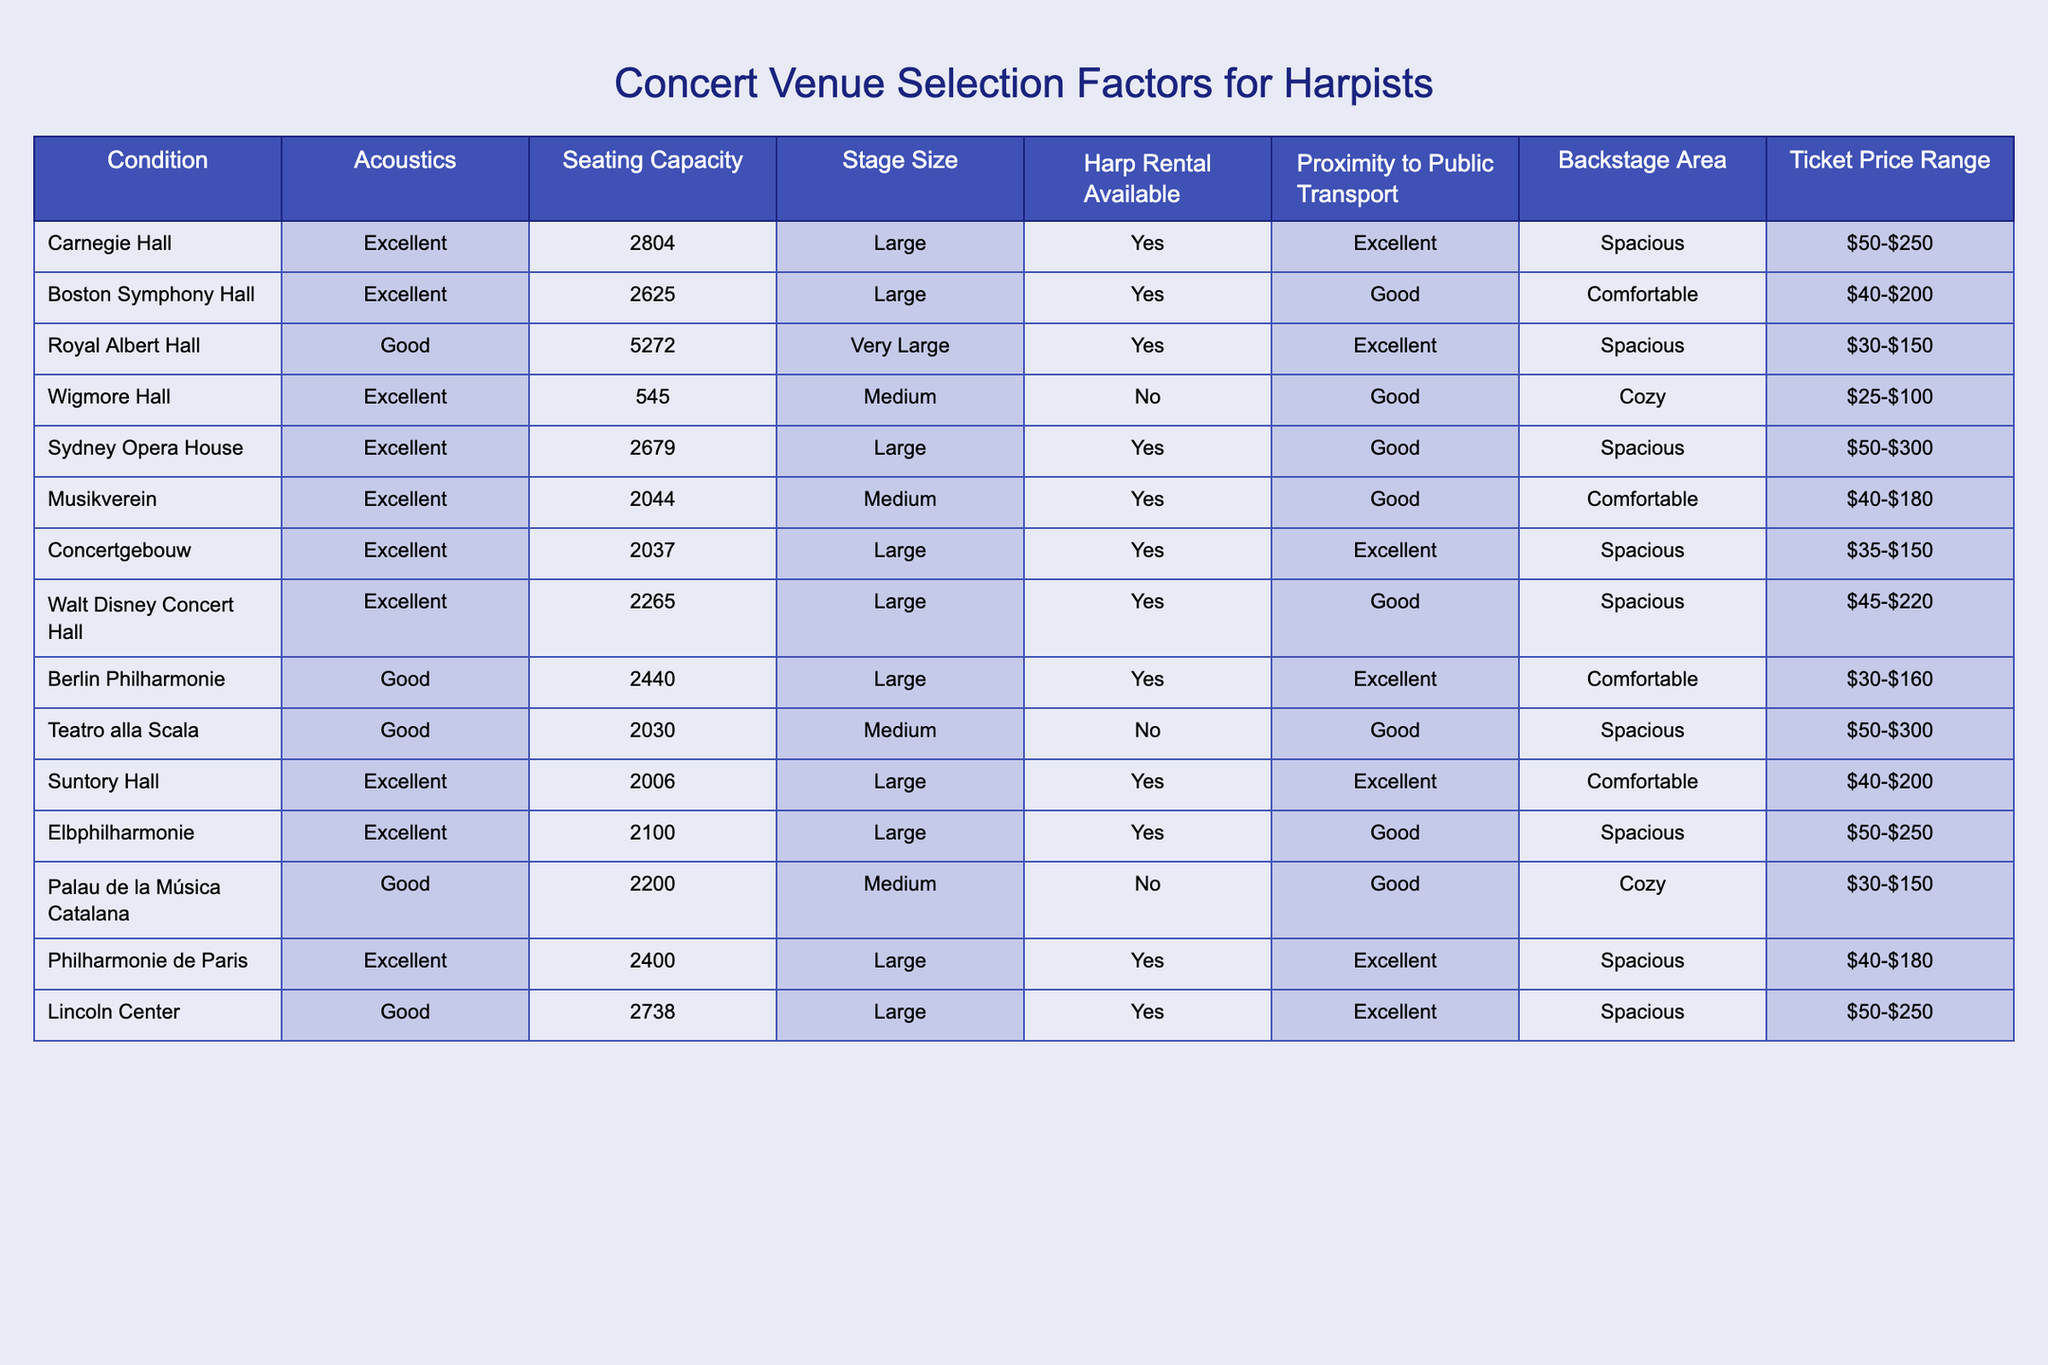What is the seating capacity of Royal Albert Hall? The seating capacity is listed in the table, where Royal Albert Hall corresponds to a capacity of 5272.
Answer: 5272 Is Harp Rental available at Wigmore Hall? The table indicates the availability of harp rental at each venue, and for Wigmore Hall, it shows "No".
Answer: No Which venue has the highest ticket price range? To determine this, the ticket price ranges from each venue must be compared. Carnegie Hall has a range of $50-$250, while the others like Sydney Opera House has $50-$300. By comparing all values, Sydney Opera House has the highest price range.
Answer: Sydney Opera House How many venues have excellent acoustics and seating capacity greater than 2500? By checking the table for venues with excellent acoustics and then filtering those with a seating capacity over 2500, we find Carnegie Hall, Boston Symphony Hall, Royal Albert Hall, and Sydney Opera House. In total, there are four venues.
Answer: 4 What is the average seating capacity of venues that offer Harp Rental? We first identify the venues that have harp rental available from the table: Carnegie Hall, Boston Symphony Hall, Royal Albert Hall, and others totaling 9. The seating capacity for those is (2804 + 2625 + 5272 + 2679 + 2044 + 2037 + 2265 + 2440 + 2738) = 23195. Dividing by the 9 venues gives the average as 23195/9 ≈ 2577.22.
Answer: Approximately 2577 Is it true that at least one venue has a cozy backstage area? Checking the backstage area descriptions in the table reveals that Wigmore Hall and Palau de la Música Catalana are marked as "Cozy". Therefore, it is true that there are venues with a cozy backstage area.
Answer: Yes Which venue has the largest stage size among those that have harp rental available? To answer, we look specifically for 'Large' or 'Very Large' stage sizes in the venues that provide harp rental. Among the applicable venues, Royal Albert Hall has a "Very Large" stage size, making it the largest.
Answer: Royal Albert Hall What is the difference in the ticket price range between the highest and lowest priced venues? The highest ticket price range is from Sydney Opera House ($50-$300) and the lowest is from Wigmore Hall ($25-$100). Calculating the differences is ($300 - $100 = $200) and ($100 - $25 = $75). The maximum difference is $200 minus $75 which equals $125.
Answer: $125 